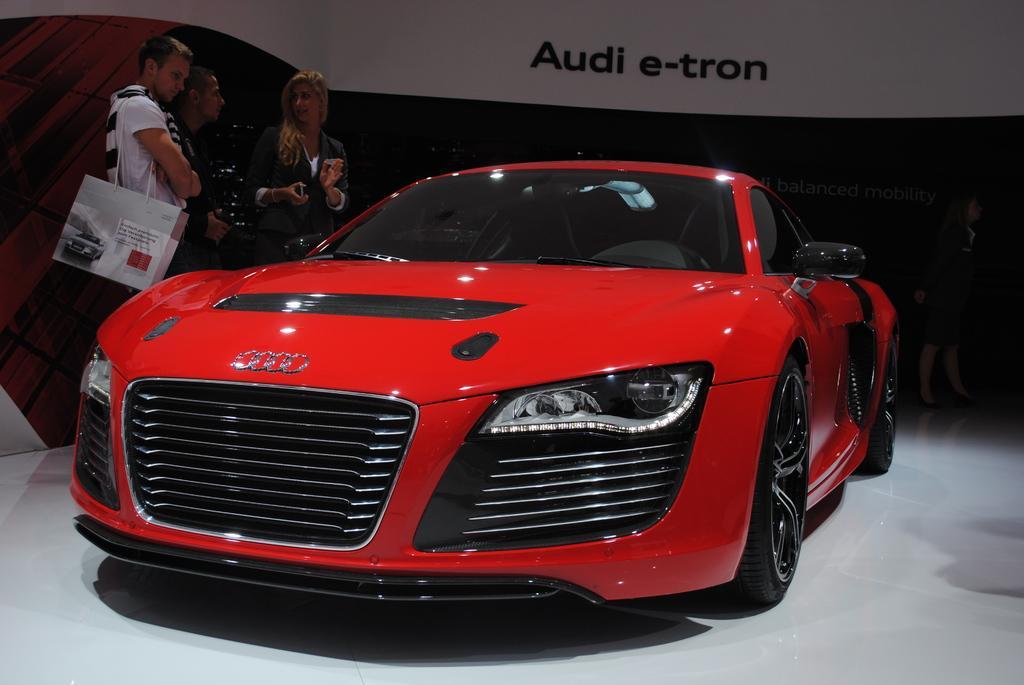Please provide a concise description of this image. In this image I can see a red colour car in the front. On the left side of this image I can see few people are standing and one of them is carrying a bag. In the background I can see something is written on the top of this image. 